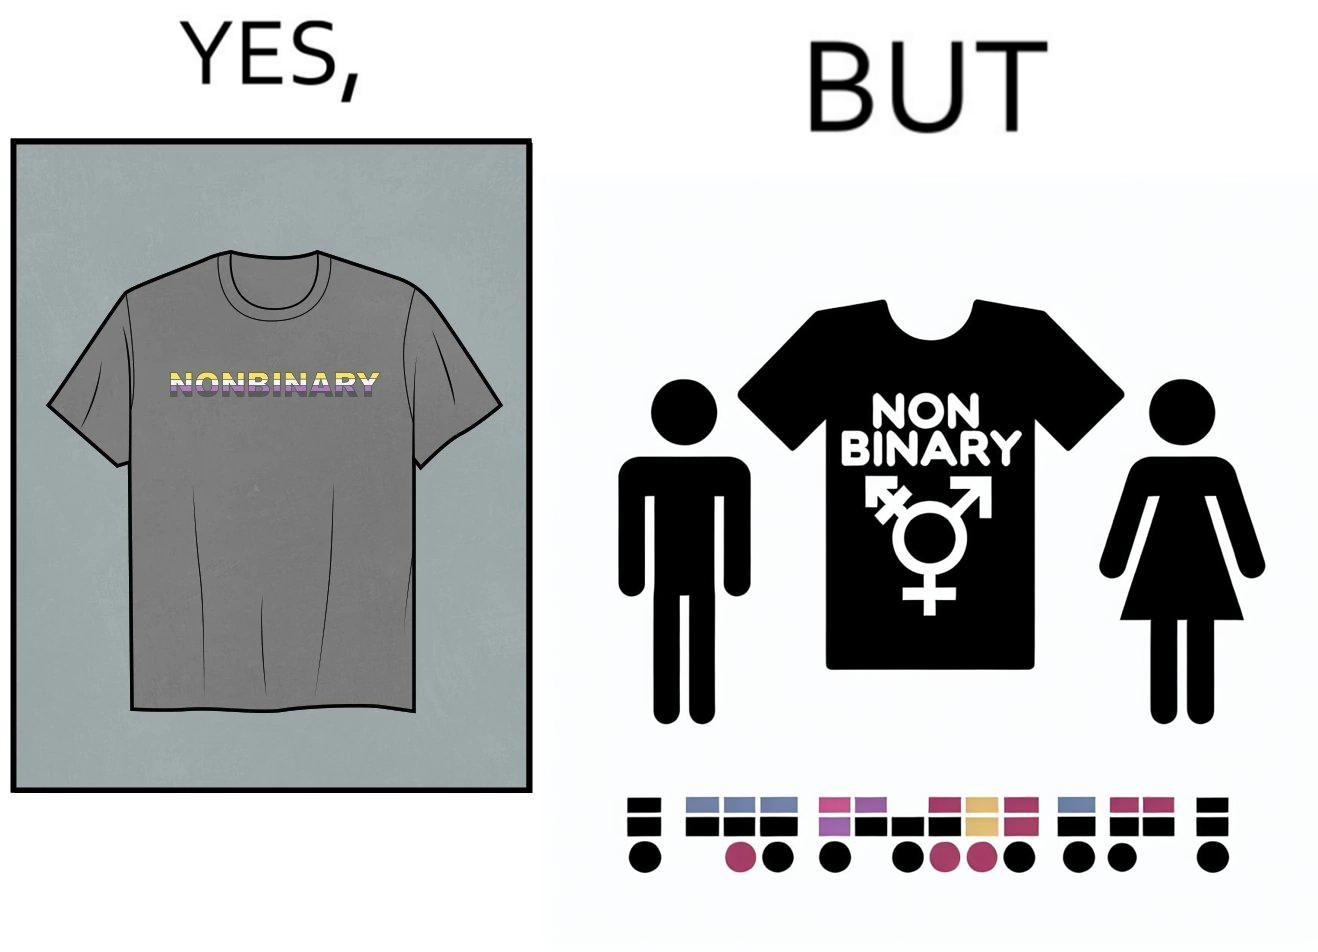Is this a satirical image? Yes, this image is satirical. 